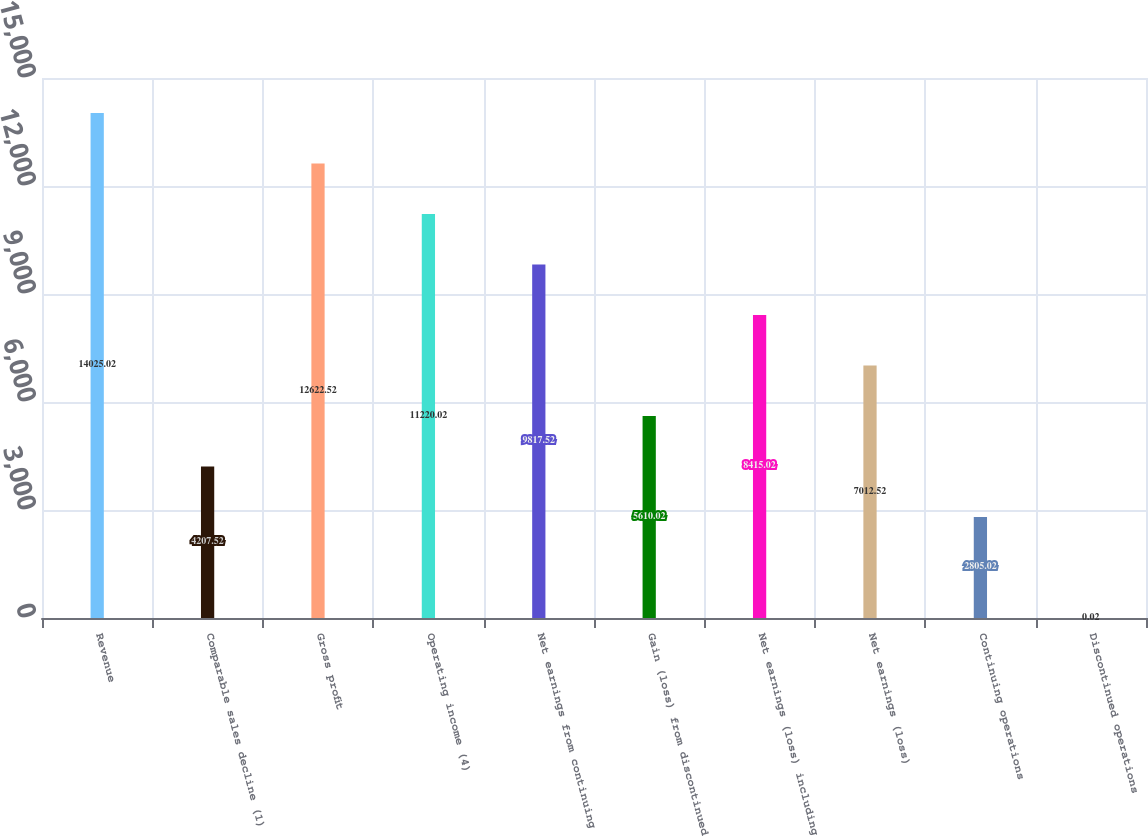Convert chart to OTSL. <chart><loc_0><loc_0><loc_500><loc_500><bar_chart><fcel>Revenue<fcel>Comparable sales decline (1)<fcel>Gross profit<fcel>Operating income (4)<fcel>Net earnings from continuing<fcel>Gain (loss) from discontinued<fcel>Net earnings (loss) including<fcel>Net earnings (loss)<fcel>Continuing operations<fcel>Discontinued operations<nl><fcel>14025<fcel>4207.52<fcel>12622.5<fcel>11220<fcel>9817.52<fcel>5610.02<fcel>8415.02<fcel>7012.52<fcel>2805.02<fcel>0.02<nl></chart> 